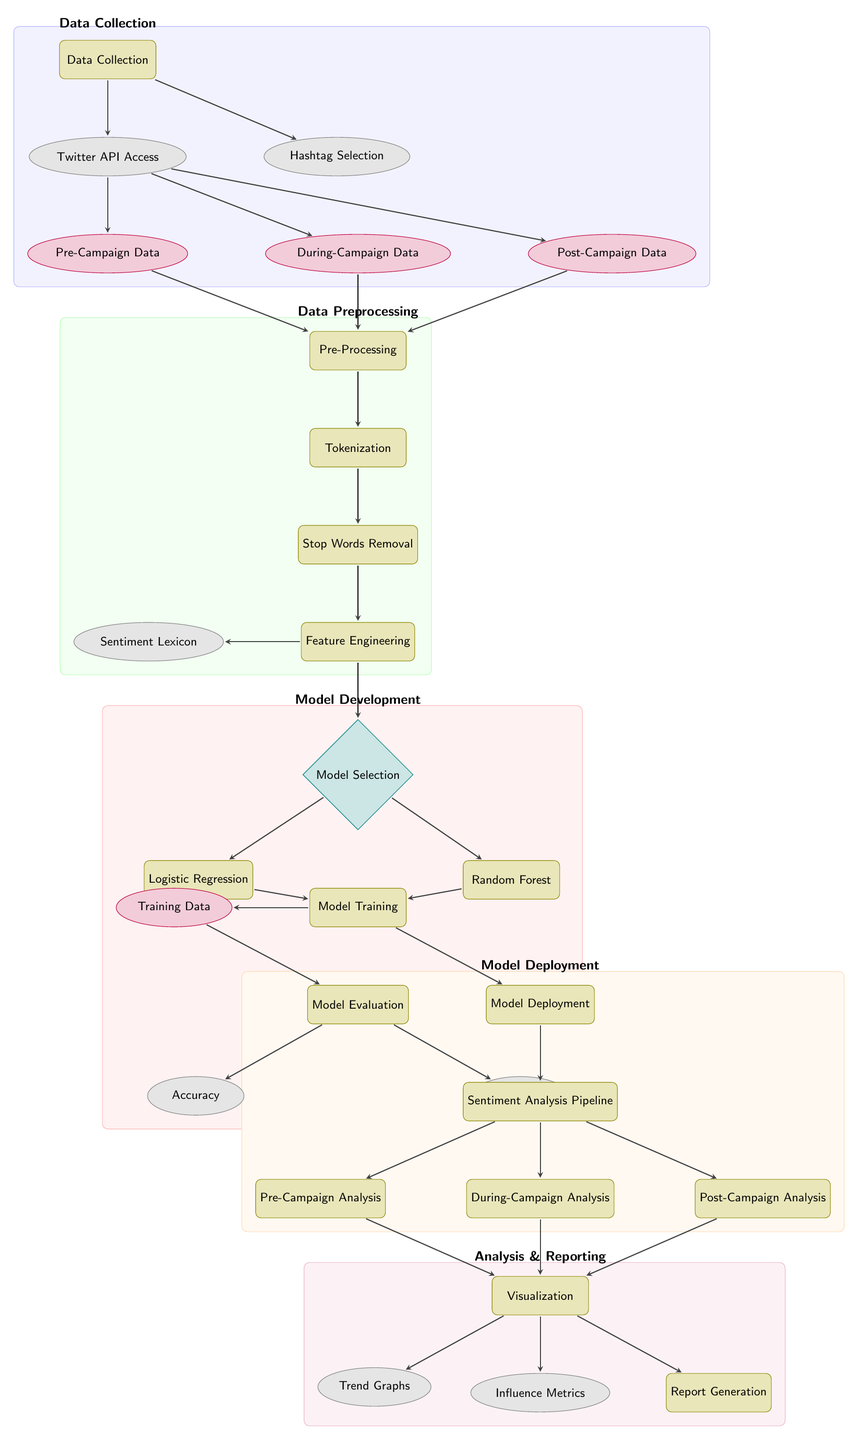What is the first step in the diagram? The diagram begins with the "Data Collection" node, which is the first process in the flow.
Answer: Data Collection How many types of data are collected during the social media sentiment analysis? There are three categories of data represented: Pre-Campaign Data, During-Campaign Data, and Post-Campaign Data.
Answer: Three Which process comes after "Stop Words Removal"? The process that follows "Stop Words Removal" is "Feature Engineering".
Answer: Feature Engineering What models are selected in the "Model Selection" node? The models specified in the diagram under "Model Selection" are "Logistic Regression" and "Random Forest".
Answer: Logistic Regression, Random Forest What two metrics are evaluated after model training? The two evaluation metrics listed are "Accuracy" and "F1 Score", which are assessed following the "Model Evaluation" stage.
Answer: Accuracy, F1 Score How do the Pre-Campaign, During-Campaign, and Post-Campaign analyses connect to the Visualization process? All three analyses connect to the "Visualization" process, indicating that the output from each analysis feeds into this stage for visualization efforts.
Answer: Connect through Sentiment Analysis Pipeline What is the purpose of the "Sentiment Lexicon" cloud in the diagram? The "Sentiment Lexicon" serves as a resource during "Feature Engineering", which helps in determining sentiment from the text data.
Answer: To assist in sentiment determination Which node represents the final output of the sentiment analysis process? The final output of the process is represented by the "Report Generation" node, which compiles the results of the sentiment analysis.
Answer: Report Generation What connects all the campaign data to the preprocessing stage? All campaign data types (Pre-Campaign, During-Campaign, and Post-Campaign) route into the "Pre-Processing" stage, indicating a common preprocessing workflow for all three types.
Answer: All connect to Pre-Processing 